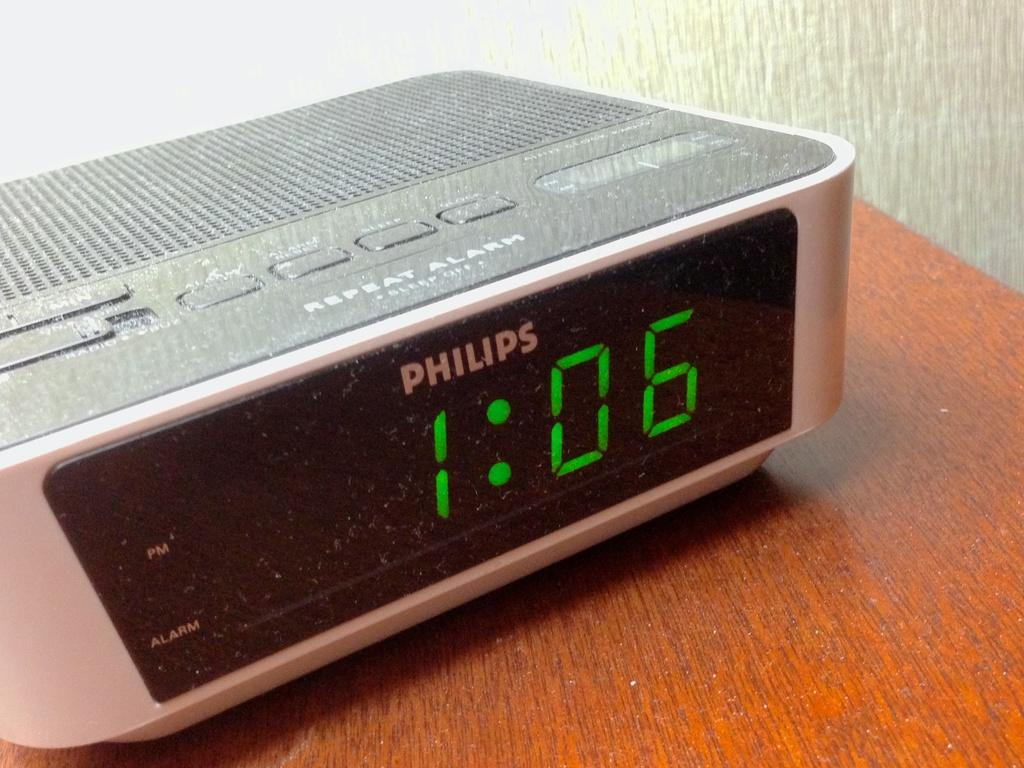<image>
Create a compact narrative representing the image presented. A Philips digtal clock displays the time of 1:06. 